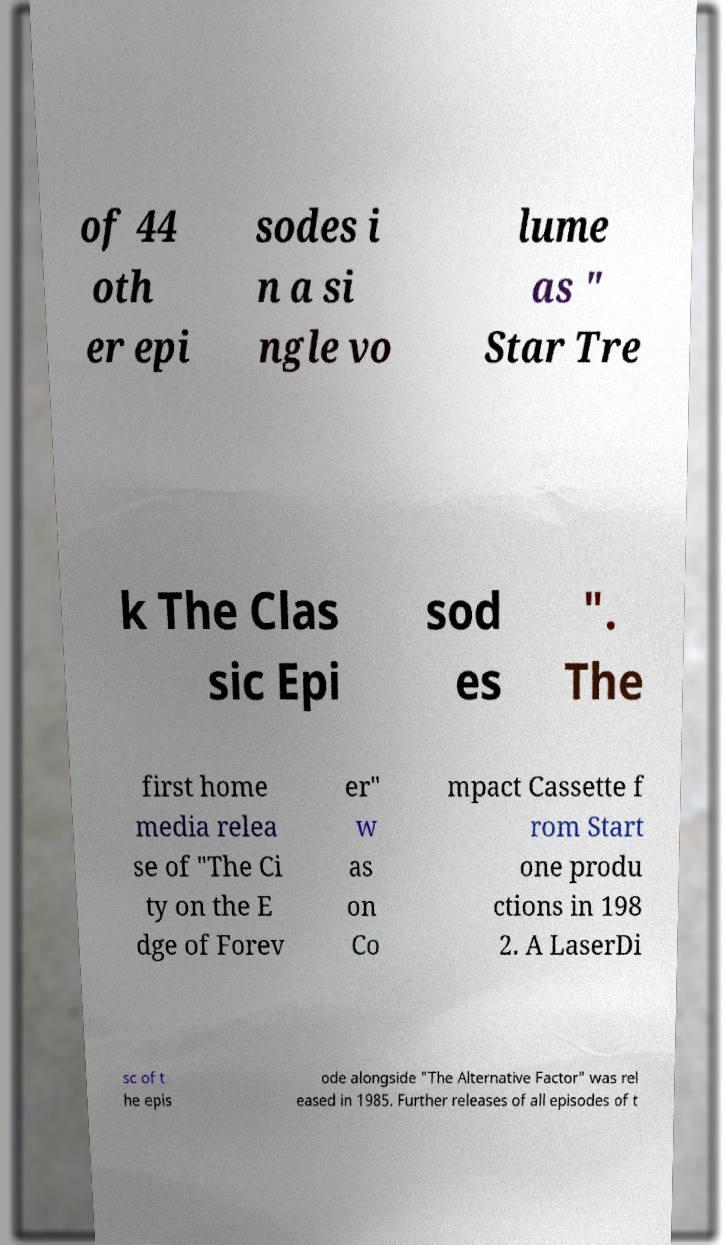There's text embedded in this image that I need extracted. Can you transcribe it verbatim? of 44 oth er epi sodes i n a si ngle vo lume as " Star Tre k The Clas sic Epi sod es ". The first home media relea se of "The Ci ty on the E dge of Forev er" w as on Co mpact Cassette f rom Start one produ ctions in 198 2. A LaserDi sc of t he epis ode alongside "The Alternative Factor" was rel eased in 1985. Further releases of all episodes of t 